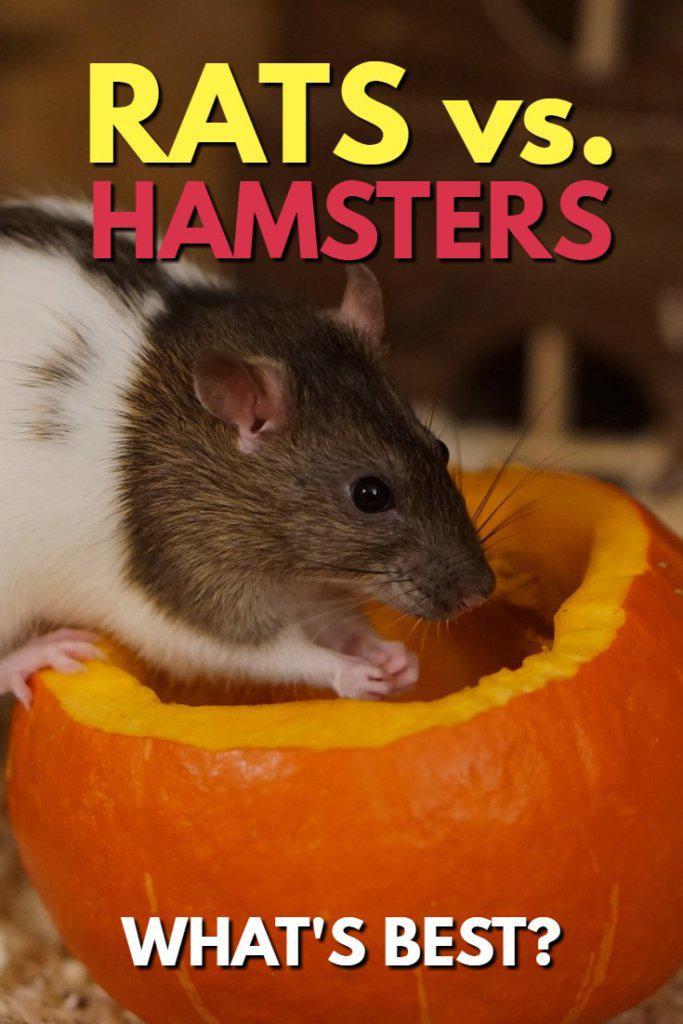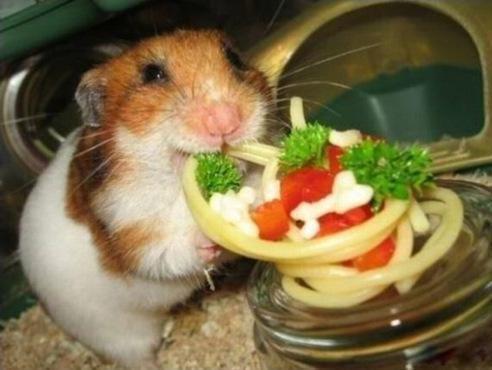The first image is the image on the left, the second image is the image on the right. Analyze the images presented: Is the assertion "THere are at least two hamsters in the image on the right." valid? Answer yes or no. No. The first image is the image on the left, the second image is the image on the right. Evaluate the accuracy of this statement regarding the images: "At least one of the animals is interacting with something.". Is it true? Answer yes or no. Yes. 